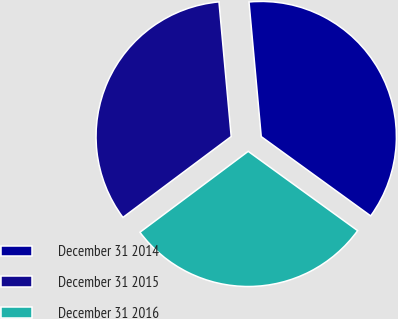Convert chart to OTSL. <chart><loc_0><loc_0><loc_500><loc_500><pie_chart><fcel>December 31 2014<fcel>December 31 2015<fcel>December 31 2016<nl><fcel>36.42%<fcel>33.77%<fcel>29.8%<nl></chart> 